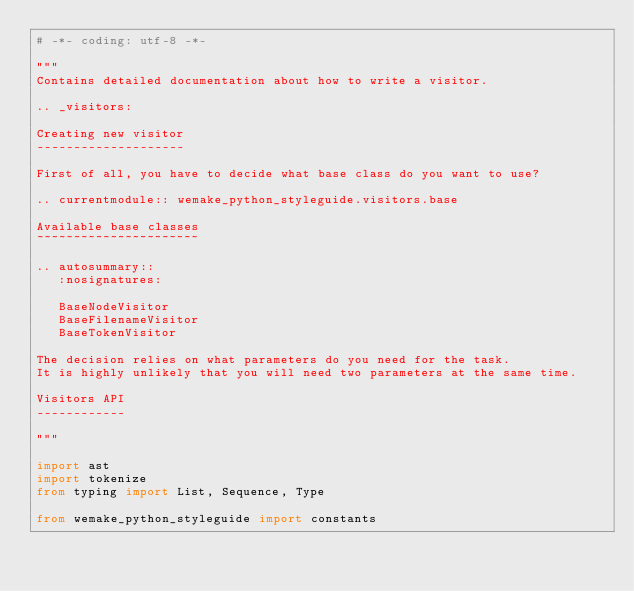Convert code to text. <code><loc_0><loc_0><loc_500><loc_500><_Python_># -*- coding: utf-8 -*-

"""
Contains detailed documentation about how to write a visitor.

.. _visitors:

Creating new visitor
--------------------

First of all, you have to decide what base class do you want to use?

.. currentmodule:: wemake_python_styleguide.visitors.base

Available base classes
~~~~~~~~~~~~~~~~~~~~~~

.. autosummary::
   :nosignatures:

   BaseNodeVisitor
   BaseFilenameVisitor
   BaseTokenVisitor

The decision relies on what parameters do you need for the task.
It is highly unlikely that you will need two parameters at the same time.

Visitors API
------------

"""

import ast
import tokenize
from typing import List, Sequence, Type

from wemake_python_styleguide import constants</code> 